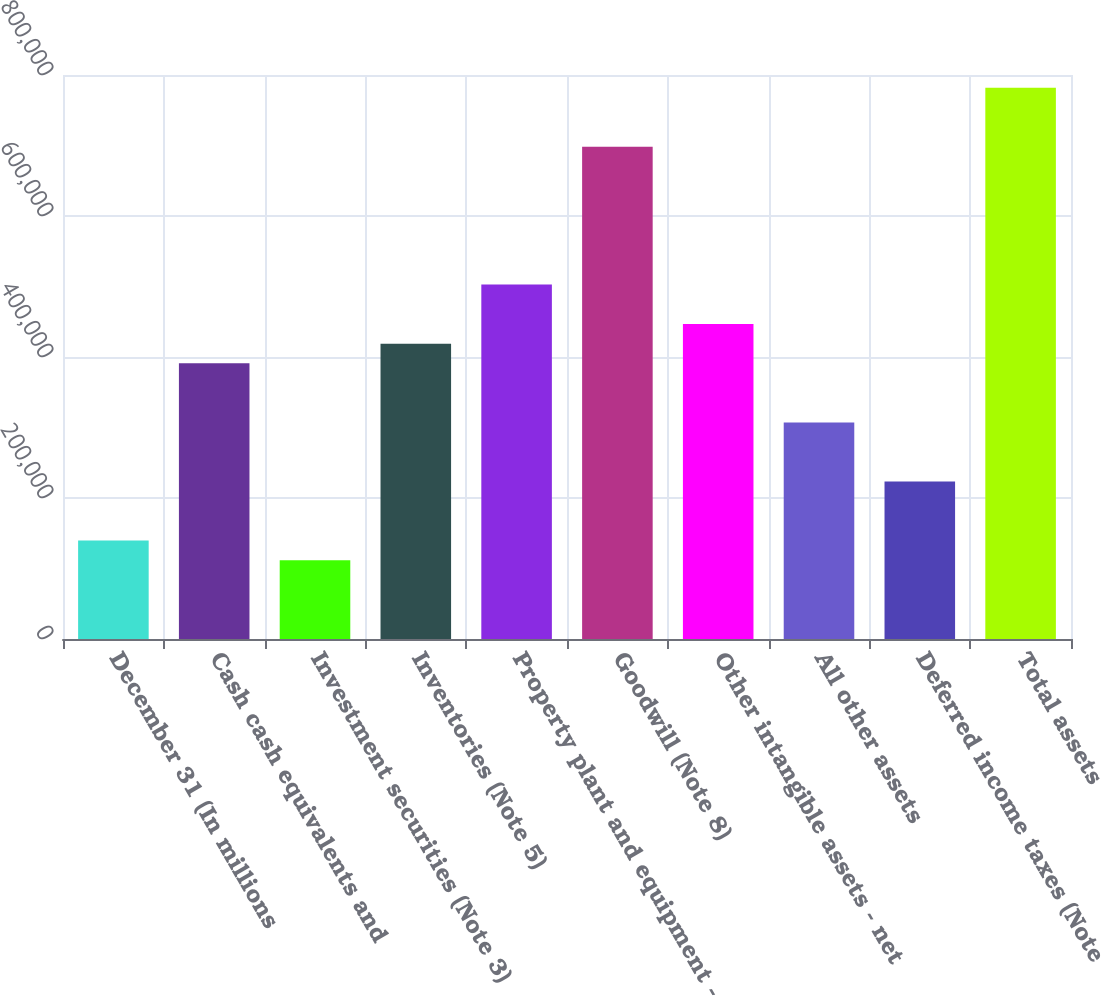Convert chart. <chart><loc_0><loc_0><loc_500><loc_500><bar_chart><fcel>December 31 (In millions<fcel>Cash cash equivalents and<fcel>Investment securities (Note 3)<fcel>Inventories (Note 5)<fcel>Property plant and equipment -<fcel>Goodwill (Note 8)<fcel>Other intangible assets - net<fcel>All other assets<fcel>Deferred income taxes (Note<fcel>Total assets<nl><fcel>139636<fcel>390971<fcel>111710<fcel>418898<fcel>502676<fcel>698158<fcel>446824<fcel>307193<fcel>223415<fcel>781937<nl></chart> 